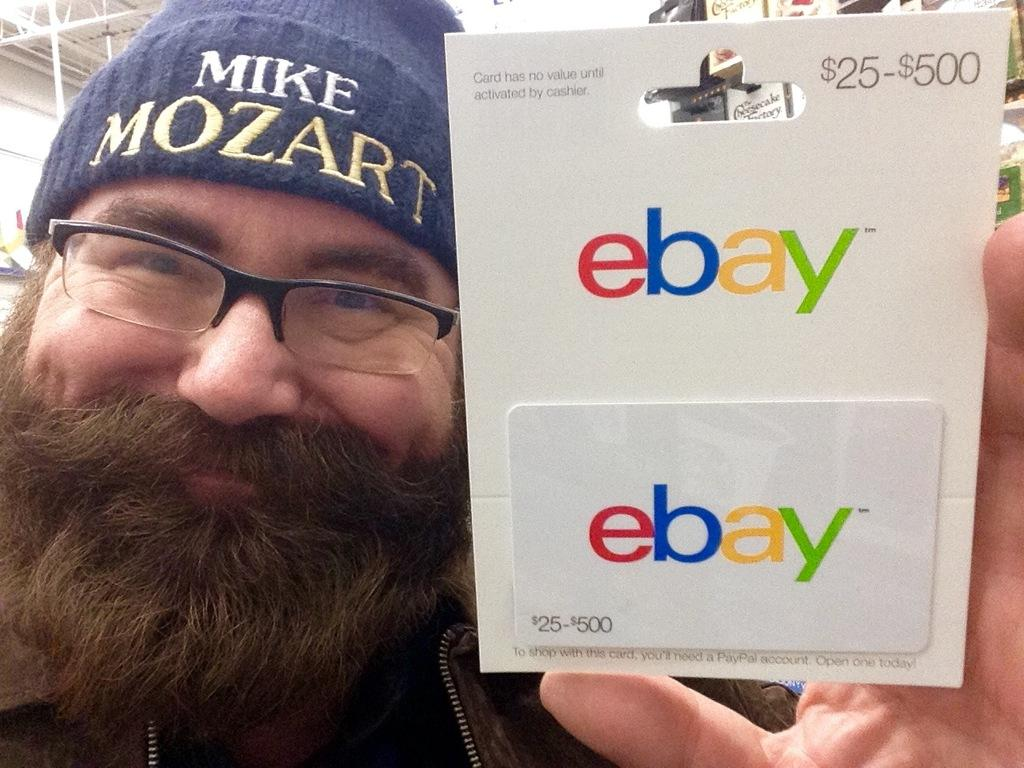What is the person in the image doing? The person is standing and holding a paper. What is the person's facial expression in the image? The person is smiling. What might the person be holding the paper for? It is not clear from the image what the person is doing with the paper, but they might be reading or presenting it. What can be seen behind the person in the image? There are products visible behind the person. What is the top left corner of the image showing? The top left corner of the image contains a roof. How does the person use the cannon in the image? There is no cannon present in the image. What level of expertise does the person have with the zipper in the image? There is no zipper present in the image. 